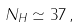Convert formula to latex. <formula><loc_0><loc_0><loc_500><loc_500>N _ { H } \simeq 3 7 \, ,</formula> 